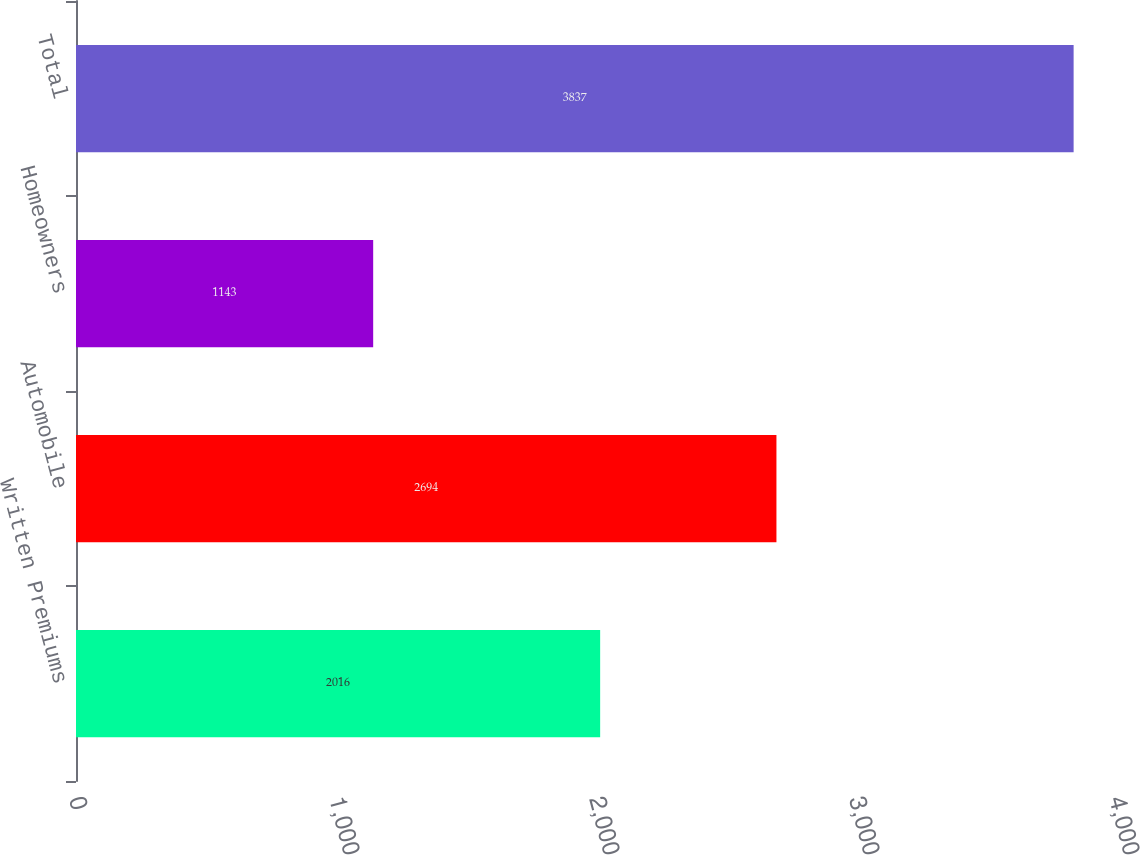Convert chart to OTSL. <chart><loc_0><loc_0><loc_500><loc_500><bar_chart><fcel>Written Premiums<fcel>Automobile<fcel>Homeowners<fcel>Total<nl><fcel>2016<fcel>2694<fcel>1143<fcel>3837<nl></chart> 